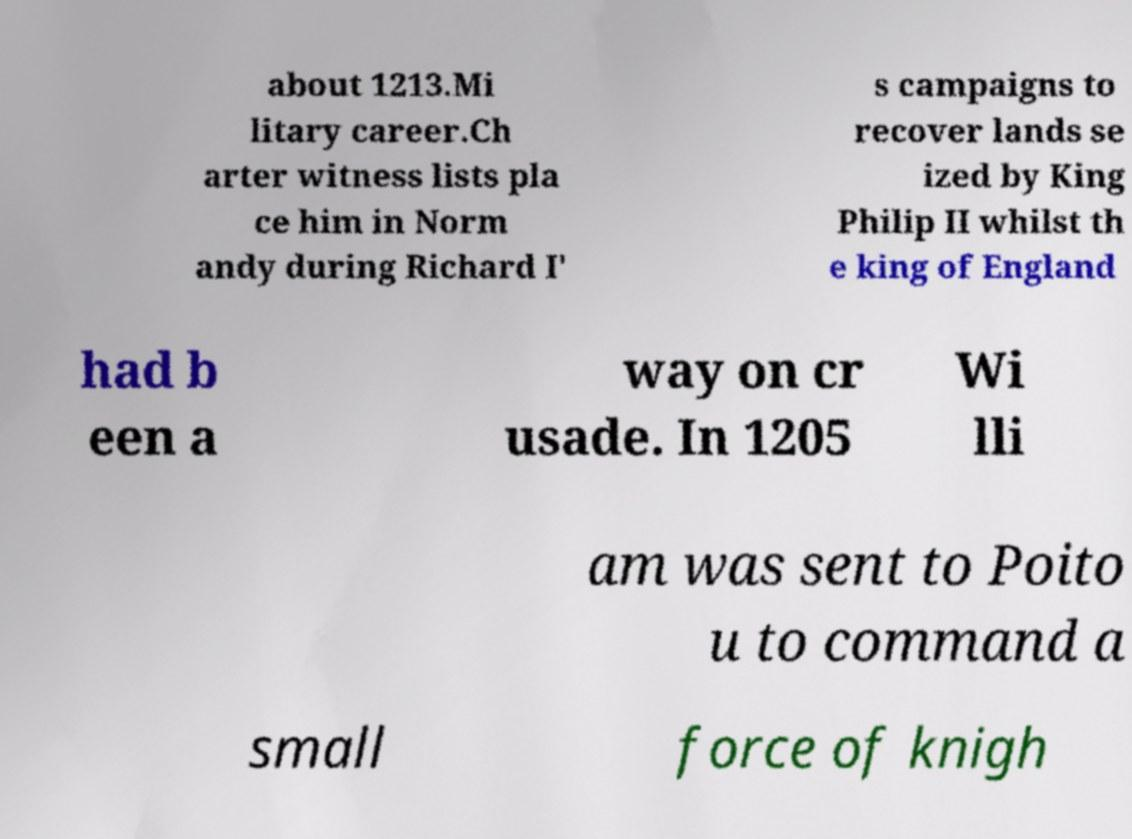For documentation purposes, I need the text within this image transcribed. Could you provide that? about 1213.Mi litary career.Ch arter witness lists pla ce him in Norm andy during Richard I' s campaigns to recover lands se ized by King Philip II whilst th e king of England had b een a way on cr usade. In 1205 Wi lli am was sent to Poito u to command a small force of knigh 